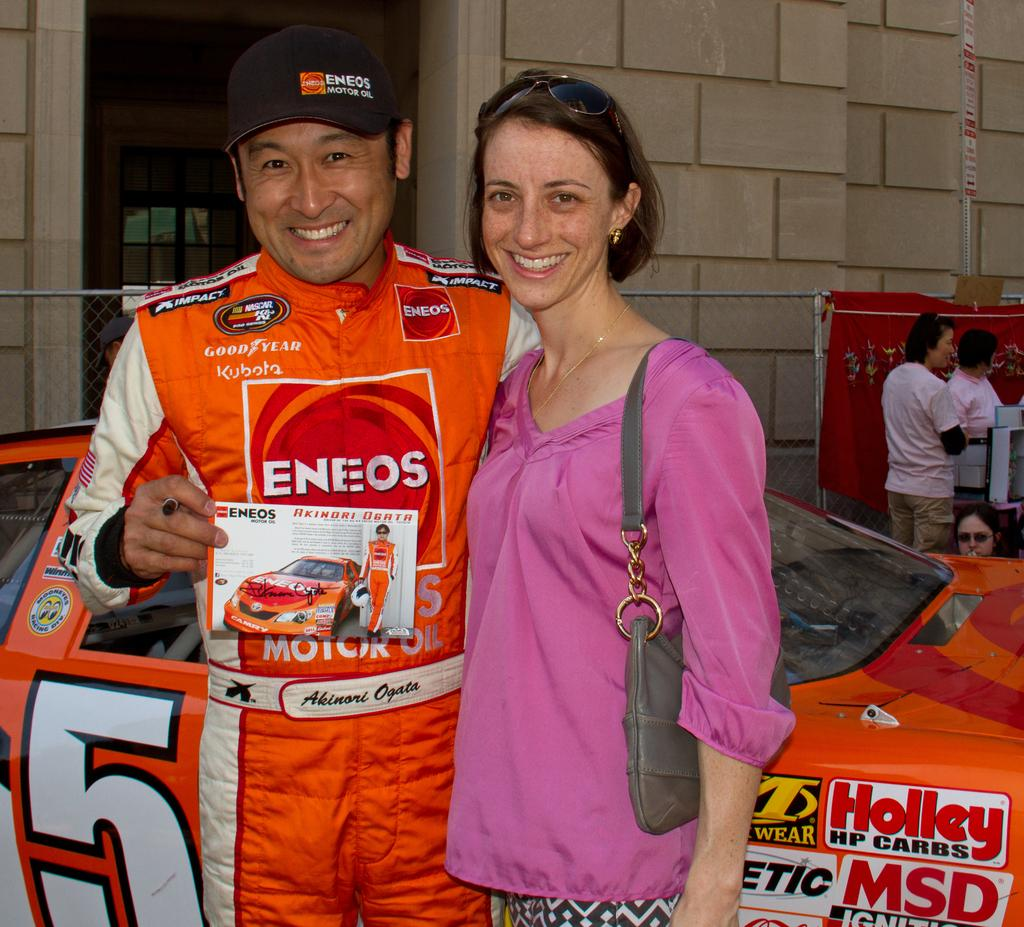<image>
Render a clear and concise summary of the photo. A woman poses with a race car driver in an orange race suit sponsored by Eneo and Good Year in front of his #5 car. 